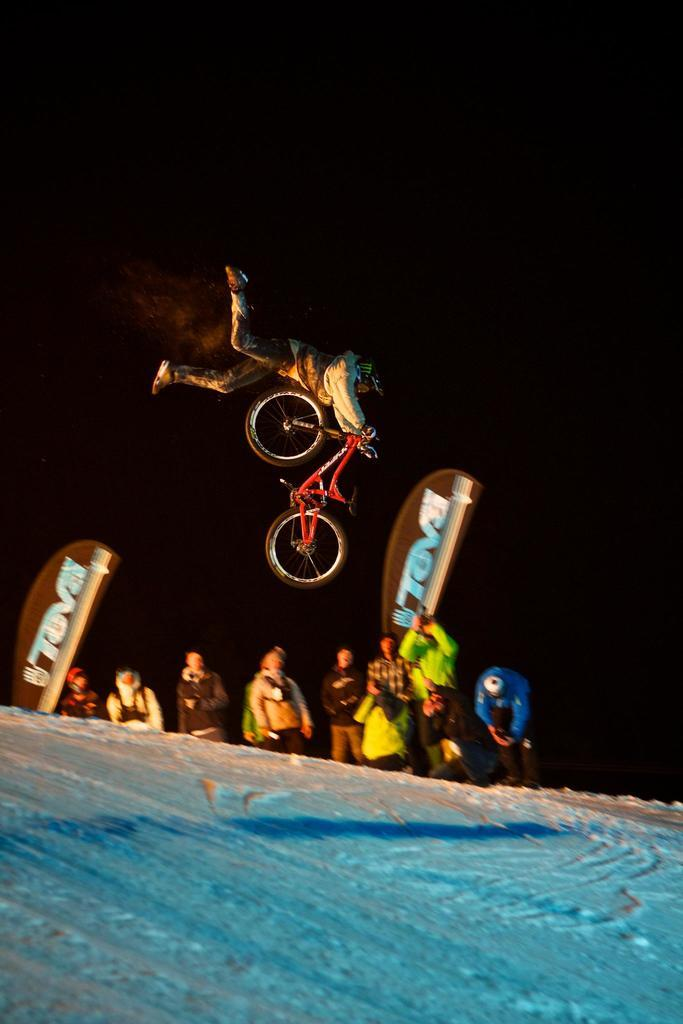What is happening in the image involving a person and a bike? There is a person and a bike in the air in the image. What can be seen in the vicinity of the person and bike? There are people standing nearby. What type of equipment is present on the path? Snowboards are present on the path. What is the weather like in the image? There is snow in the image, indicating a cold or wintry environment. How does the island contribute to the scene in the image? There is no island present in the image; it features a person and a bike in the air, people standing nearby, snowboards on the path, and snow. What type of addition is being performed by the person in the image? There is no addition being performed by the person in the image; they are simply riding a bike in the air. 